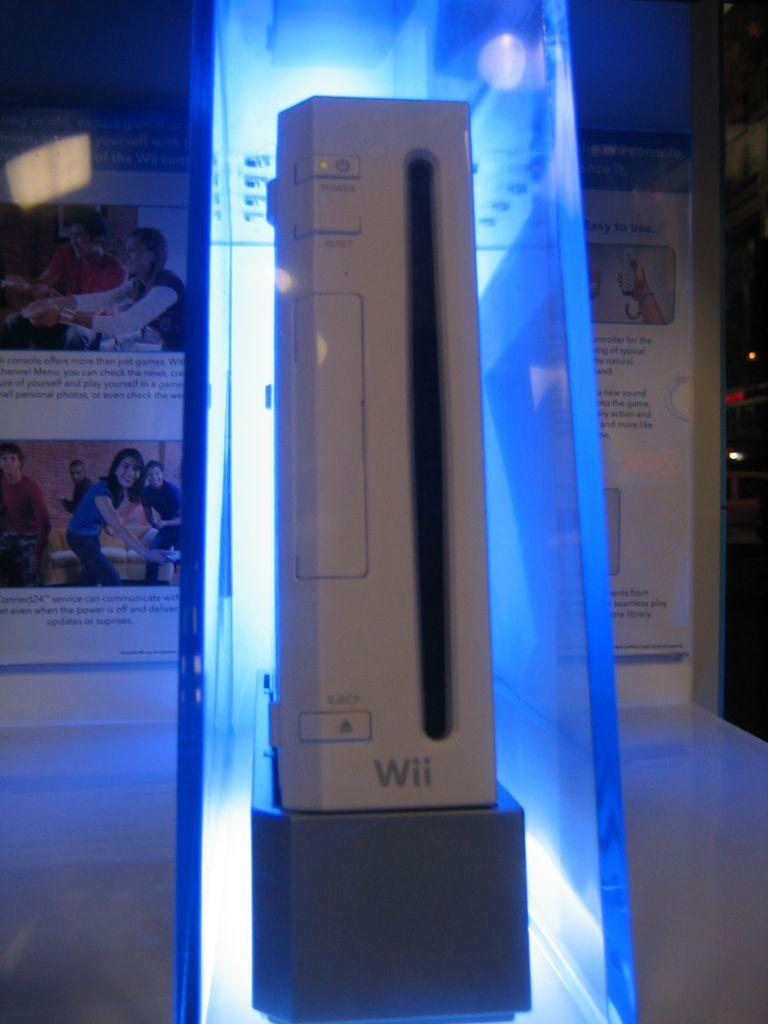What is placed in the glass in the image? There is a white-colored object placed in a glass. What can be seen in the background of the image? There is a poster in the background of the image. How does the ship balance itself in the image? There is no ship present in the image, so it cannot be balanced. 